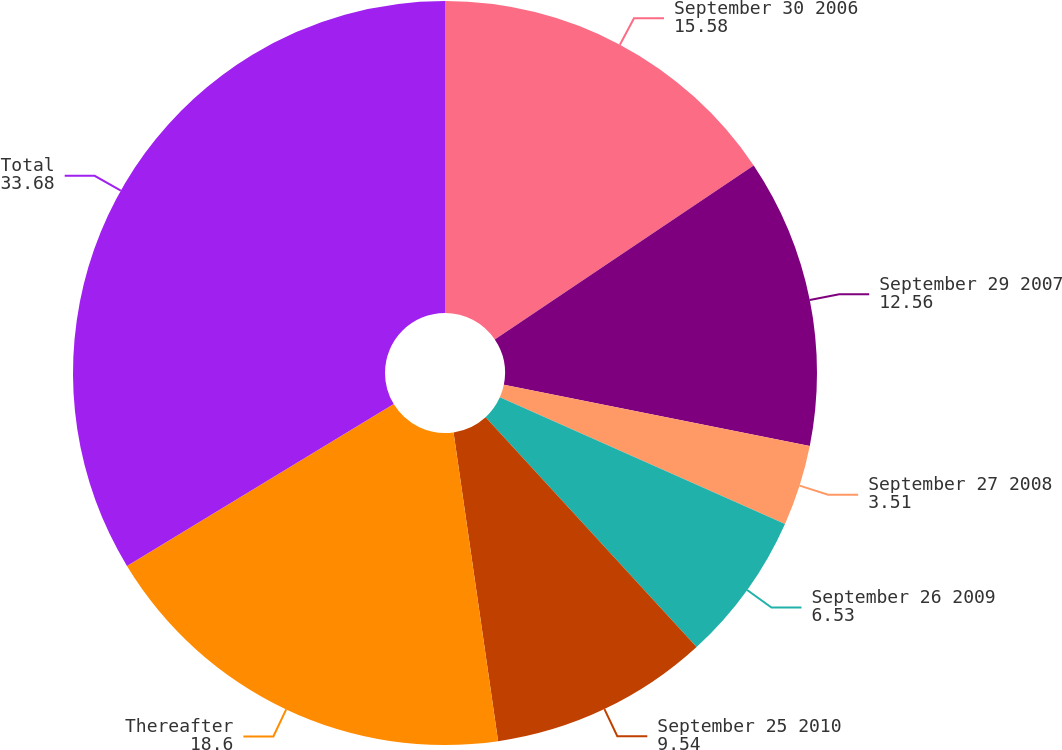<chart> <loc_0><loc_0><loc_500><loc_500><pie_chart><fcel>September 30 2006<fcel>September 29 2007<fcel>September 27 2008<fcel>September 26 2009<fcel>September 25 2010<fcel>Thereafter<fcel>Total<nl><fcel>15.58%<fcel>12.56%<fcel>3.51%<fcel>6.53%<fcel>9.54%<fcel>18.6%<fcel>33.68%<nl></chart> 